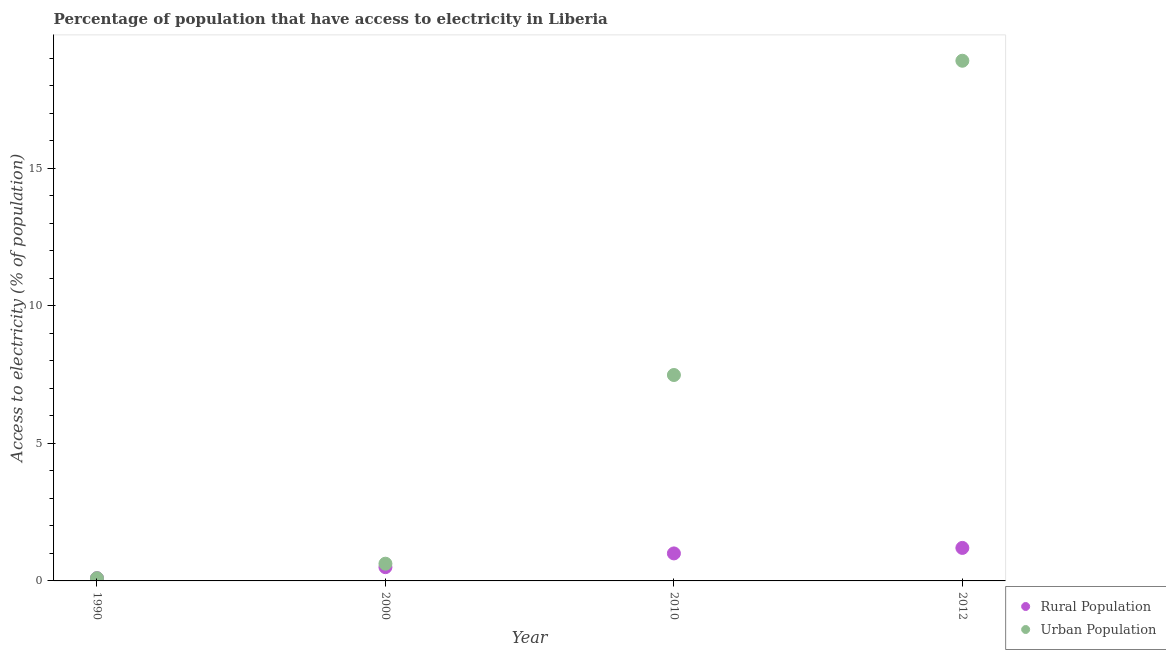How many different coloured dotlines are there?
Give a very brief answer. 2. Across all years, what is the maximum percentage of urban population having access to electricity?
Your response must be concise. 18.91. Across all years, what is the minimum percentage of rural population having access to electricity?
Offer a terse response. 0.1. In which year was the percentage of urban population having access to electricity maximum?
Ensure brevity in your answer.  2012. In which year was the percentage of rural population having access to electricity minimum?
Make the answer very short. 1990. What is the total percentage of urban population having access to electricity in the graph?
Your response must be concise. 27.12. What is the difference between the percentage of urban population having access to electricity in 1990 and that in 2012?
Your response must be concise. -18.81. What is the difference between the percentage of urban population having access to electricity in 2010 and the percentage of rural population having access to electricity in 2000?
Keep it short and to the point. 6.99. What is the average percentage of urban population having access to electricity per year?
Your answer should be very brief. 6.78. In the year 1990, what is the difference between the percentage of rural population having access to electricity and percentage of urban population having access to electricity?
Keep it short and to the point. 0. What is the difference between the highest and the second highest percentage of urban population having access to electricity?
Provide a short and direct response. 11.42. What is the difference between the highest and the lowest percentage of rural population having access to electricity?
Keep it short and to the point. 1.1. In how many years, is the percentage of urban population having access to electricity greater than the average percentage of urban population having access to electricity taken over all years?
Your answer should be very brief. 2. Is the sum of the percentage of rural population having access to electricity in 2000 and 2010 greater than the maximum percentage of urban population having access to electricity across all years?
Keep it short and to the point. No. Is the percentage of urban population having access to electricity strictly less than the percentage of rural population having access to electricity over the years?
Give a very brief answer. No. How many years are there in the graph?
Ensure brevity in your answer.  4. What is the difference between two consecutive major ticks on the Y-axis?
Make the answer very short. 5. Does the graph contain any zero values?
Make the answer very short. No. Where does the legend appear in the graph?
Give a very brief answer. Bottom right. How many legend labels are there?
Your answer should be very brief. 2. What is the title of the graph?
Offer a terse response. Percentage of population that have access to electricity in Liberia. Does "Male" appear as one of the legend labels in the graph?
Ensure brevity in your answer.  No. What is the label or title of the Y-axis?
Offer a very short reply. Access to electricity (% of population). What is the Access to electricity (% of population) in Urban Population in 1990?
Give a very brief answer. 0.1. What is the Access to electricity (% of population) in Urban Population in 2000?
Give a very brief answer. 0.63. What is the Access to electricity (% of population) in Urban Population in 2010?
Provide a short and direct response. 7.49. What is the Access to electricity (% of population) of Rural Population in 2012?
Offer a very short reply. 1.2. What is the Access to electricity (% of population) of Urban Population in 2012?
Offer a terse response. 18.91. Across all years, what is the maximum Access to electricity (% of population) of Rural Population?
Keep it short and to the point. 1.2. Across all years, what is the maximum Access to electricity (% of population) of Urban Population?
Make the answer very short. 18.91. Across all years, what is the minimum Access to electricity (% of population) in Rural Population?
Offer a very short reply. 0.1. Across all years, what is the minimum Access to electricity (% of population) of Urban Population?
Offer a terse response. 0.1. What is the total Access to electricity (% of population) in Rural Population in the graph?
Give a very brief answer. 2.8. What is the total Access to electricity (% of population) of Urban Population in the graph?
Your response must be concise. 27.12. What is the difference between the Access to electricity (% of population) in Rural Population in 1990 and that in 2000?
Your answer should be very brief. -0.4. What is the difference between the Access to electricity (% of population) of Urban Population in 1990 and that in 2000?
Make the answer very short. -0.53. What is the difference between the Access to electricity (% of population) of Rural Population in 1990 and that in 2010?
Make the answer very short. -0.9. What is the difference between the Access to electricity (% of population) in Urban Population in 1990 and that in 2010?
Give a very brief answer. -7.39. What is the difference between the Access to electricity (% of population) in Rural Population in 1990 and that in 2012?
Make the answer very short. -1.1. What is the difference between the Access to electricity (% of population) of Urban Population in 1990 and that in 2012?
Ensure brevity in your answer.  -18.81. What is the difference between the Access to electricity (% of population) in Rural Population in 2000 and that in 2010?
Your answer should be very brief. -0.5. What is the difference between the Access to electricity (% of population) in Urban Population in 2000 and that in 2010?
Give a very brief answer. -6.86. What is the difference between the Access to electricity (% of population) in Urban Population in 2000 and that in 2012?
Your answer should be very brief. -18.28. What is the difference between the Access to electricity (% of population) of Urban Population in 2010 and that in 2012?
Offer a very short reply. -11.42. What is the difference between the Access to electricity (% of population) of Rural Population in 1990 and the Access to electricity (% of population) of Urban Population in 2000?
Your answer should be compact. -0.53. What is the difference between the Access to electricity (% of population) in Rural Population in 1990 and the Access to electricity (% of population) in Urban Population in 2010?
Offer a very short reply. -7.39. What is the difference between the Access to electricity (% of population) in Rural Population in 1990 and the Access to electricity (% of population) in Urban Population in 2012?
Offer a very short reply. -18.81. What is the difference between the Access to electricity (% of population) of Rural Population in 2000 and the Access to electricity (% of population) of Urban Population in 2010?
Provide a short and direct response. -6.99. What is the difference between the Access to electricity (% of population) in Rural Population in 2000 and the Access to electricity (% of population) in Urban Population in 2012?
Give a very brief answer. -18.41. What is the difference between the Access to electricity (% of population) in Rural Population in 2010 and the Access to electricity (% of population) in Urban Population in 2012?
Make the answer very short. -17.91. What is the average Access to electricity (% of population) in Rural Population per year?
Give a very brief answer. 0.7. What is the average Access to electricity (% of population) of Urban Population per year?
Your answer should be compact. 6.78. In the year 1990, what is the difference between the Access to electricity (% of population) in Rural Population and Access to electricity (% of population) in Urban Population?
Provide a succinct answer. 0. In the year 2000, what is the difference between the Access to electricity (% of population) of Rural Population and Access to electricity (% of population) of Urban Population?
Provide a succinct answer. -0.13. In the year 2010, what is the difference between the Access to electricity (% of population) in Rural Population and Access to electricity (% of population) in Urban Population?
Your response must be concise. -6.49. In the year 2012, what is the difference between the Access to electricity (% of population) of Rural Population and Access to electricity (% of population) of Urban Population?
Provide a succinct answer. -17.71. What is the ratio of the Access to electricity (% of population) of Urban Population in 1990 to that in 2000?
Ensure brevity in your answer.  0.16. What is the ratio of the Access to electricity (% of population) in Urban Population in 1990 to that in 2010?
Your response must be concise. 0.01. What is the ratio of the Access to electricity (% of population) in Rural Population in 1990 to that in 2012?
Give a very brief answer. 0.08. What is the ratio of the Access to electricity (% of population) in Urban Population in 1990 to that in 2012?
Keep it short and to the point. 0.01. What is the ratio of the Access to electricity (% of population) of Rural Population in 2000 to that in 2010?
Provide a short and direct response. 0.5. What is the ratio of the Access to electricity (% of population) of Urban Population in 2000 to that in 2010?
Your answer should be very brief. 0.08. What is the ratio of the Access to electricity (% of population) in Rural Population in 2000 to that in 2012?
Make the answer very short. 0.42. What is the ratio of the Access to electricity (% of population) in Urban Population in 2000 to that in 2012?
Offer a very short reply. 0.03. What is the ratio of the Access to electricity (% of population) of Urban Population in 2010 to that in 2012?
Provide a succinct answer. 0.4. What is the difference between the highest and the second highest Access to electricity (% of population) in Urban Population?
Your answer should be very brief. 11.42. What is the difference between the highest and the lowest Access to electricity (% of population) of Urban Population?
Your response must be concise. 18.81. 